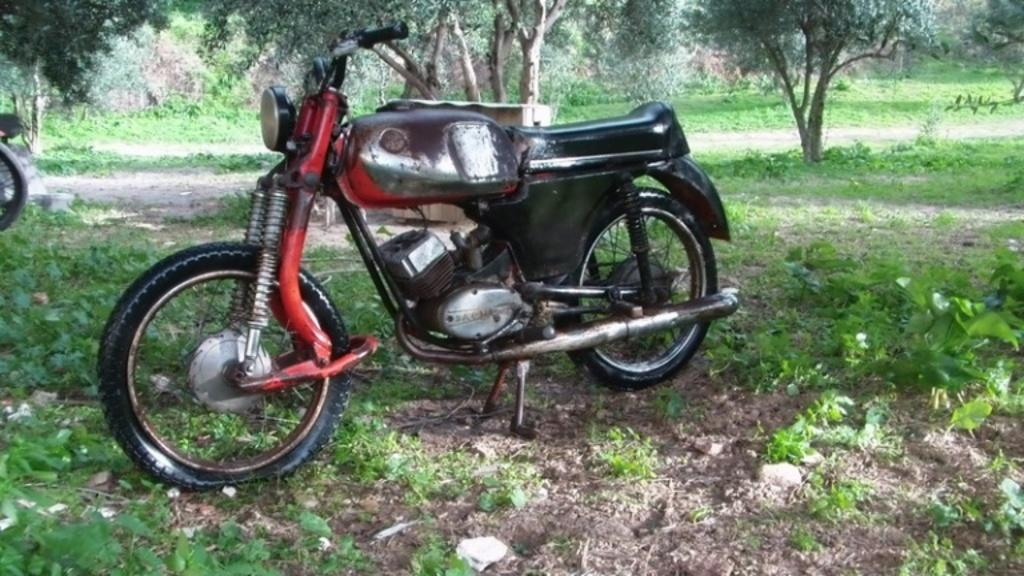What type of vehicle is on the ground in the image? There is a motorbike on the ground in the image. What type of terrain is visible in the image? Grass is visible in the image. What can be seen in the background of the image? There are trees in the background of the image. What type of cushion is being offered to the motorbike in the image? There is no cushion present in the image, nor is anything being offered to the motorbike. 